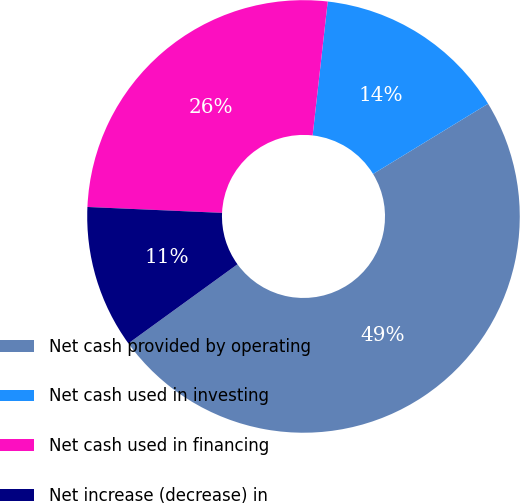Convert chart to OTSL. <chart><loc_0><loc_0><loc_500><loc_500><pie_chart><fcel>Net cash provided by operating<fcel>Net cash used in investing<fcel>Net cash used in financing<fcel>Net increase (decrease) in<nl><fcel>48.74%<fcel>14.49%<fcel>26.09%<fcel>10.68%<nl></chart> 